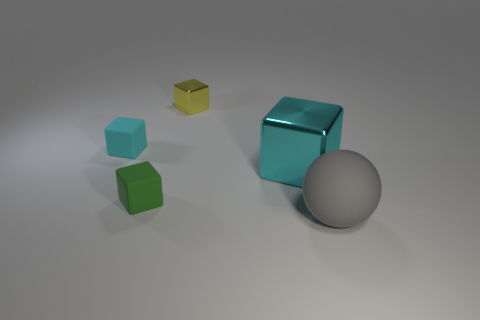Add 4 tiny yellow metal cubes. How many objects exist? 9 Subtract all cubes. How many objects are left? 1 Add 2 gray matte objects. How many gray matte objects exist? 3 Subtract 0 blue cylinders. How many objects are left? 5 Subtract all small gray shiny balls. Subtract all tiny cyan rubber things. How many objects are left? 4 Add 4 tiny green cubes. How many tiny green cubes are left? 5 